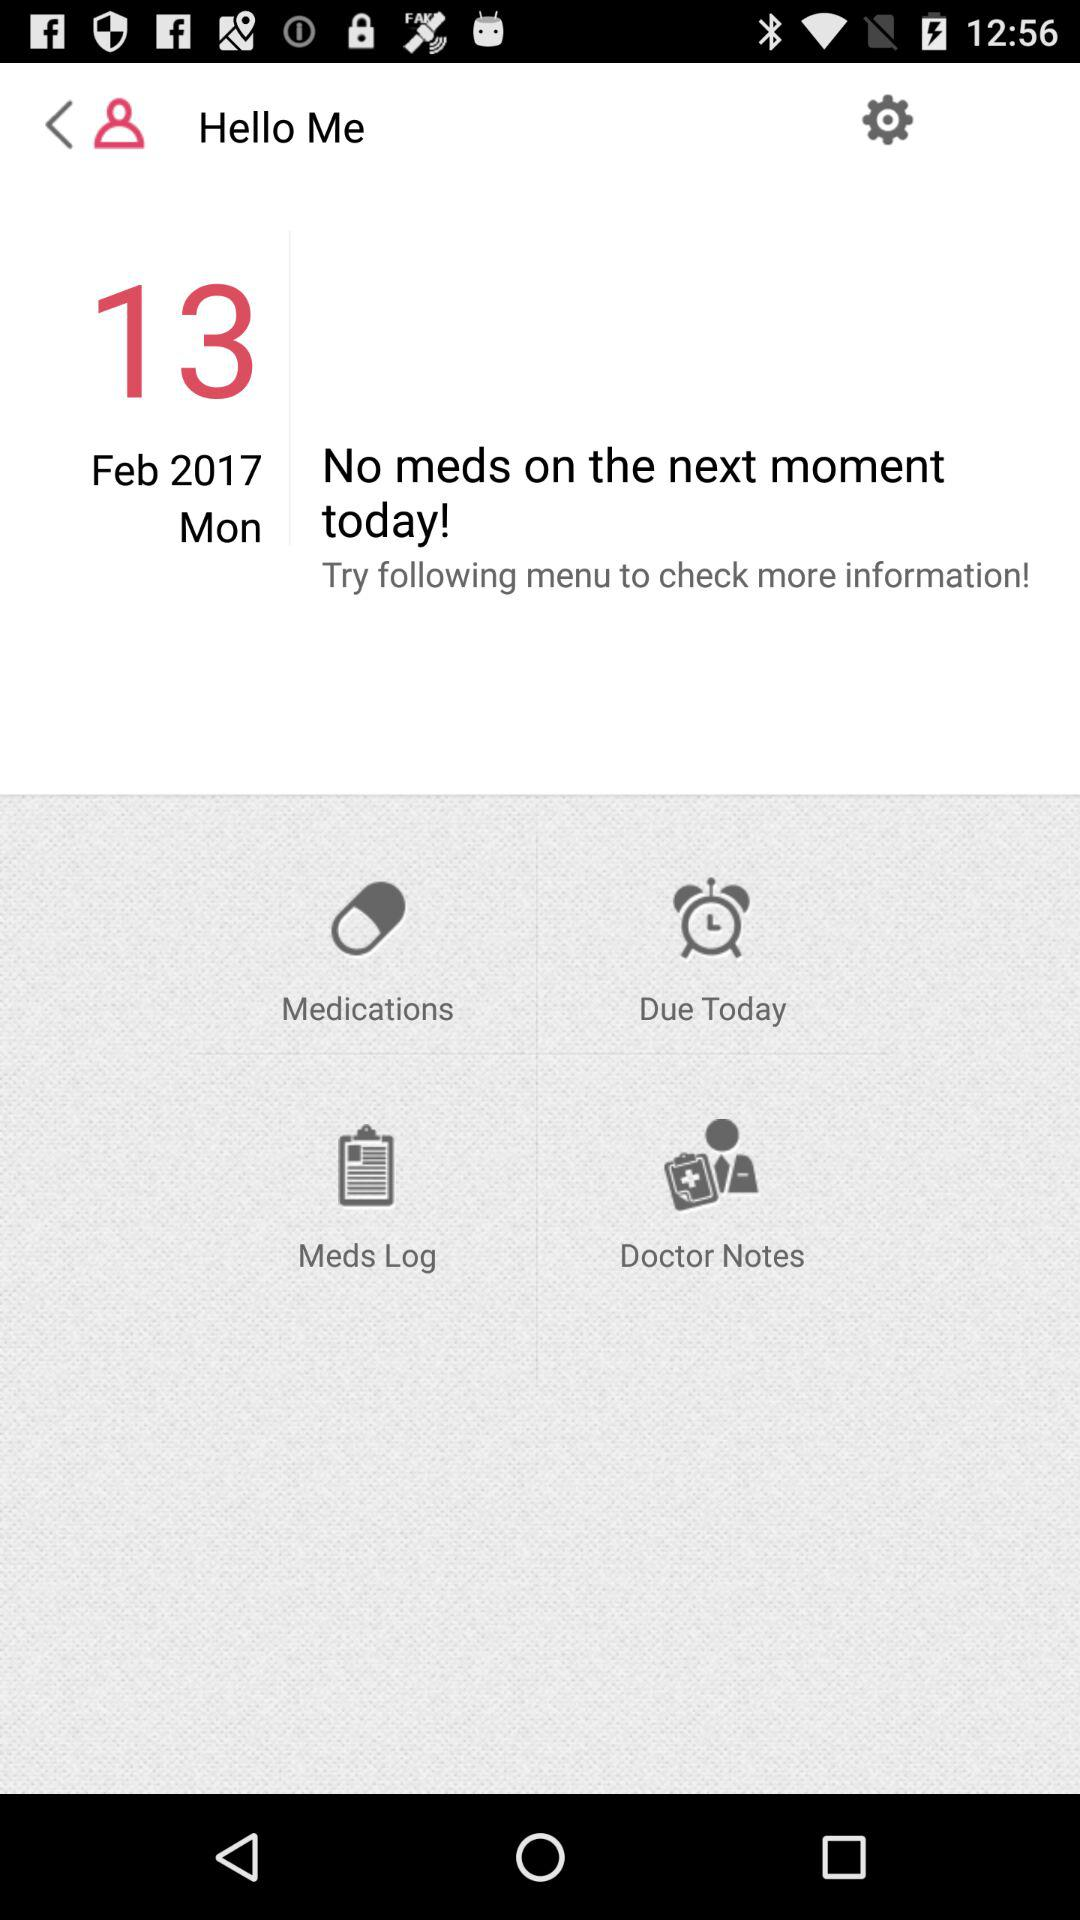Are there any meds for the next moment? There are no meds for the next month. 